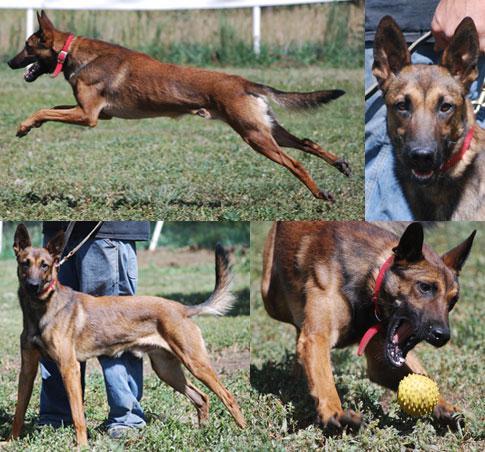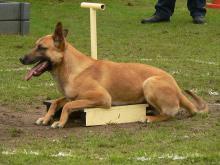The first image is the image on the left, the second image is the image on the right. Considering the images on both sides, is "The dog in the image on the right is lying in a grassy area." valid? Answer yes or no. Yes. The first image is the image on the left, the second image is the image on the right. Examine the images to the left and right. Is the description "An image shows someone wearing jeans standing behind a german shepherd dog." accurate? Answer yes or no. Yes. 